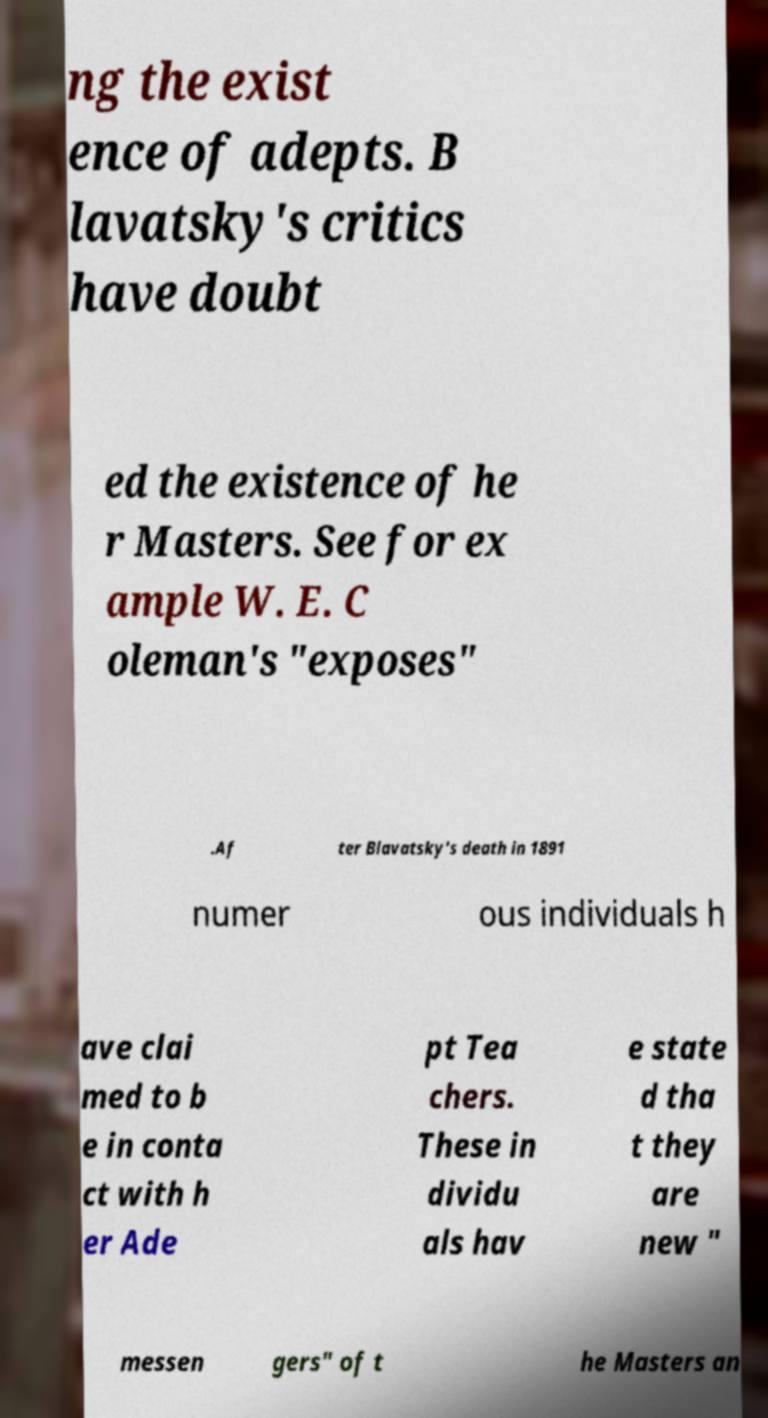For documentation purposes, I need the text within this image transcribed. Could you provide that? ng the exist ence of adepts. B lavatsky's critics have doubt ed the existence of he r Masters. See for ex ample W. E. C oleman's "exposes" .Af ter Blavatsky's death in 1891 numer ous individuals h ave clai med to b e in conta ct with h er Ade pt Tea chers. These in dividu als hav e state d tha t they are new " messen gers" of t he Masters an 